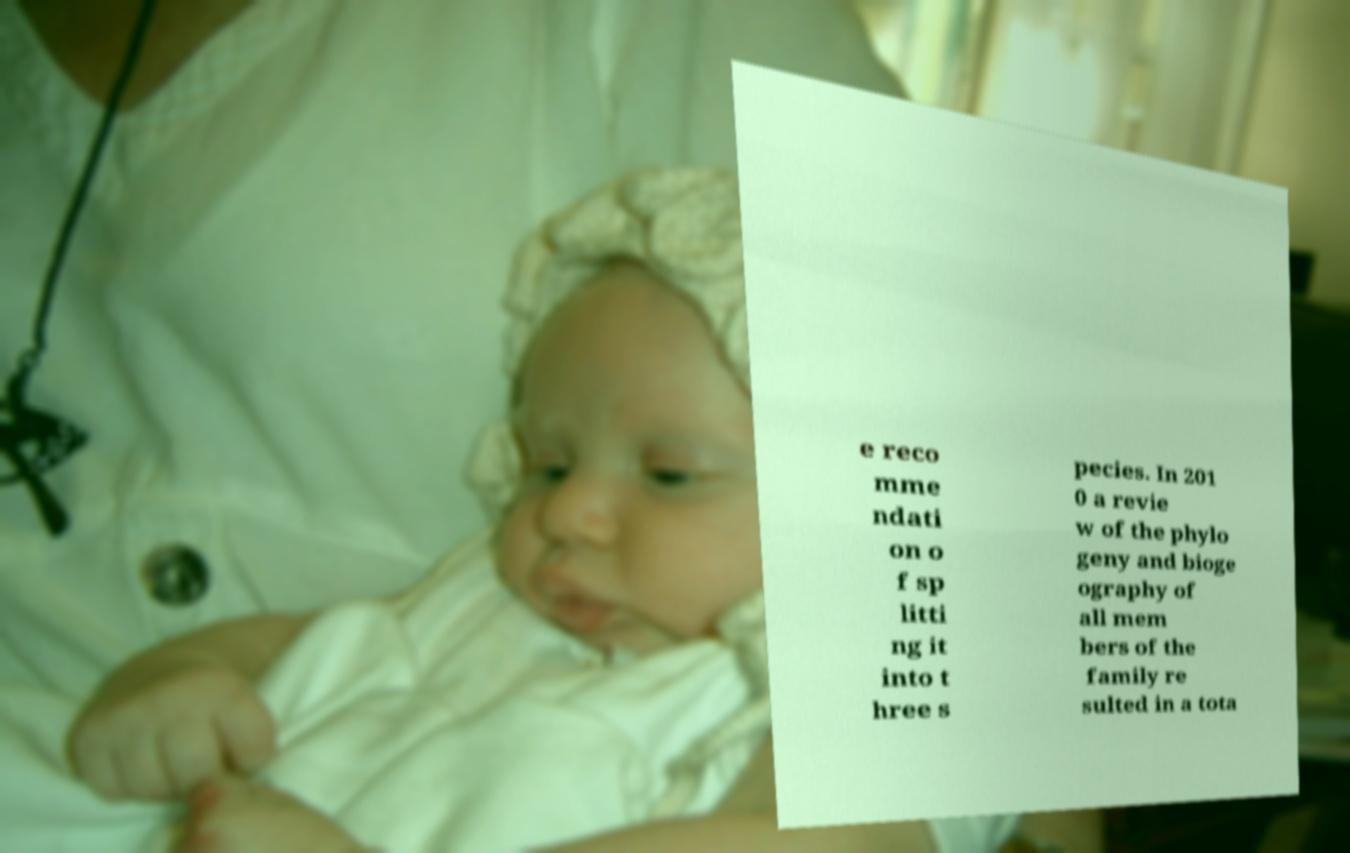I need the written content from this picture converted into text. Can you do that? e reco mme ndati on o f sp litti ng it into t hree s pecies. In 201 0 a revie w of the phylo geny and bioge ography of all mem bers of the family re sulted in a tota 